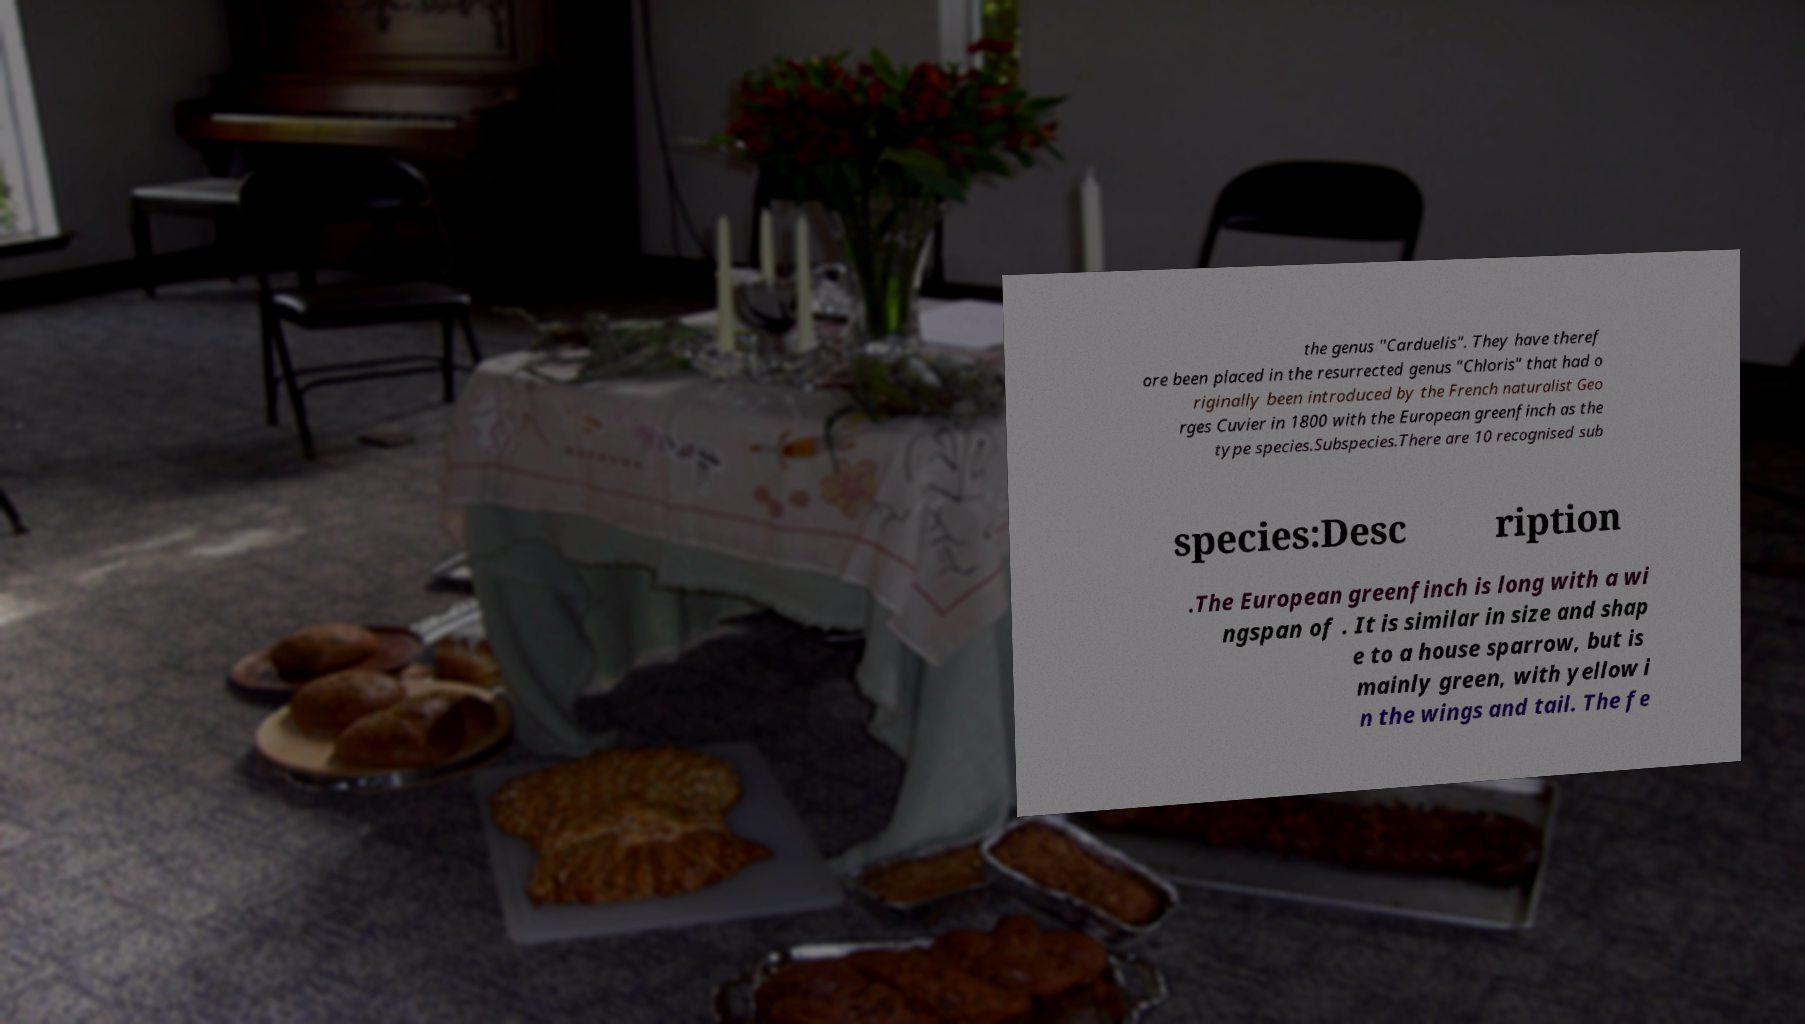Can you accurately transcribe the text from the provided image for me? the genus "Carduelis". They have theref ore been placed in the resurrected genus "Chloris" that had o riginally been introduced by the French naturalist Geo rges Cuvier in 1800 with the European greenfinch as the type species.Subspecies.There are 10 recognised sub species:Desc ription .The European greenfinch is long with a wi ngspan of . It is similar in size and shap e to a house sparrow, but is mainly green, with yellow i n the wings and tail. The fe 